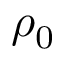<formula> <loc_0><loc_0><loc_500><loc_500>\rho _ { 0 }</formula> 